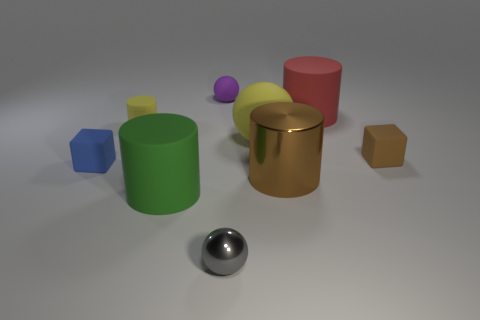There is a large metal thing; does it have the same color as the tiny ball that is behind the large green matte thing?
Ensure brevity in your answer.  No. Is there a red thing that has the same shape as the gray shiny object?
Your answer should be compact. No. What number of things are either large matte objects or yellow things on the right side of the small yellow rubber cylinder?
Offer a very short reply. 3. How many other objects are the same material as the big red thing?
Make the answer very short. 6. How many things are large shiny spheres or balls?
Your answer should be compact. 3. Is the number of tiny matte things right of the big brown metallic thing greater than the number of yellow balls to the left of the tiny purple rubber ball?
Give a very brief answer. Yes. There is a rubber block left of the small shiny ball; is it the same color as the tiny ball behind the brown rubber cube?
Your response must be concise. No. How big is the yellow thing that is left of the tiny ball that is in front of the small cube behind the blue matte cube?
Make the answer very short. Small. The other tiny metal object that is the same shape as the purple object is what color?
Give a very brief answer. Gray. Is the number of yellow cylinders that are behind the small purple sphere greater than the number of green shiny objects?
Provide a succinct answer. No. 